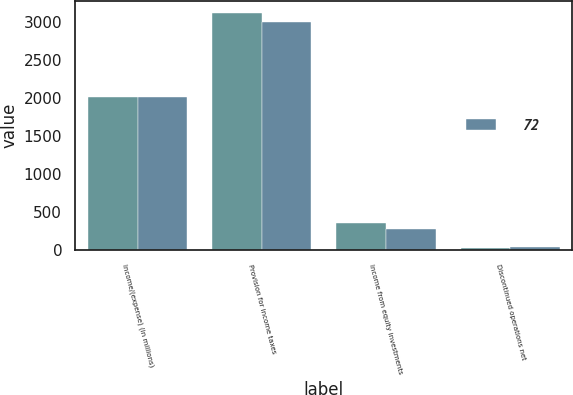<chart> <loc_0><loc_0><loc_500><loc_500><stacked_bar_chart><ecel><fcel>Income/(expense) (in millions)<fcel>Provision for income taxes<fcel>Income from equity investments<fcel>Discontinued operations net<nl><fcel>nan<fcel>2012<fcel>3118<fcel>363<fcel>37<nl><fcel>72<fcel>2010<fcel>2995<fcel>277<fcel>39<nl></chart> 